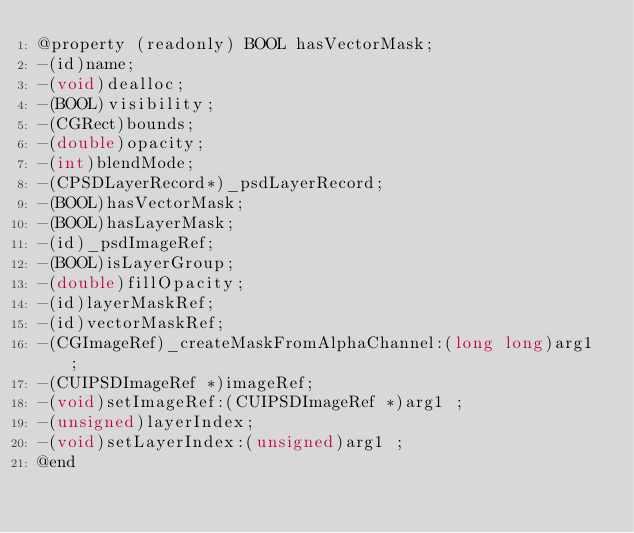Convert code to text. <code><loc_0><loc_0><loc_500><loc_500><_C_>@property (readonly) BOOL hasVectorMask; 
-(id)name;
-(void)dealloc;
-(BOOL)visibility;
-(CGRect)bounds;
-(double)opacity;
-(int)blendMode;
-(CPSDLayerRecord*)_psdLayerRecord;
-(BOOL)hasVectorMask;
-(BOOL)hasLayerMask;
-(id)_psdImageRef;
-(BOOL)isLayerGroup;
-(double)fillOpacity;
-(id)layerMaskRef;
-(id)vectorMaskRef;
-(CGImageRef)_createMaskFromAlphaChannel:(long long)arg1 ;
-(CUIPSDImageRef *)imageRef;
-(void)setImageRef:(CUIPSDImageRef *)arg1 ;
-(unsigned)layerIndex;
-(void)setLayerIndex:(unsigned)arg1 ;
@end

</code> 